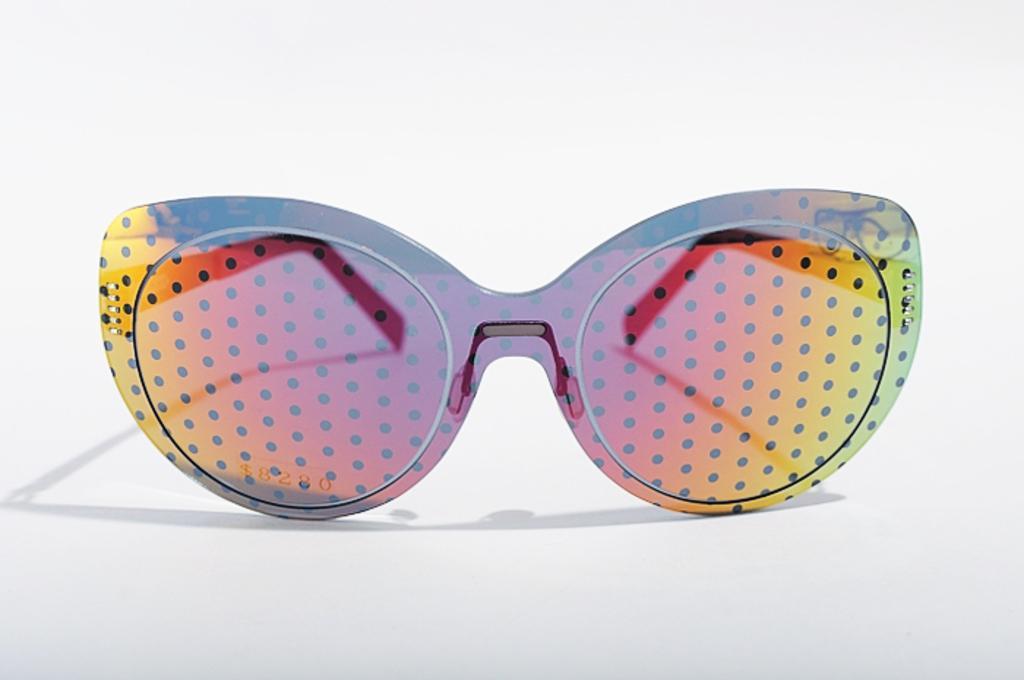Can you describe this image briefly? In this image there is goggles. On goggles there are different colours having dots on it. Background is white in colour. 